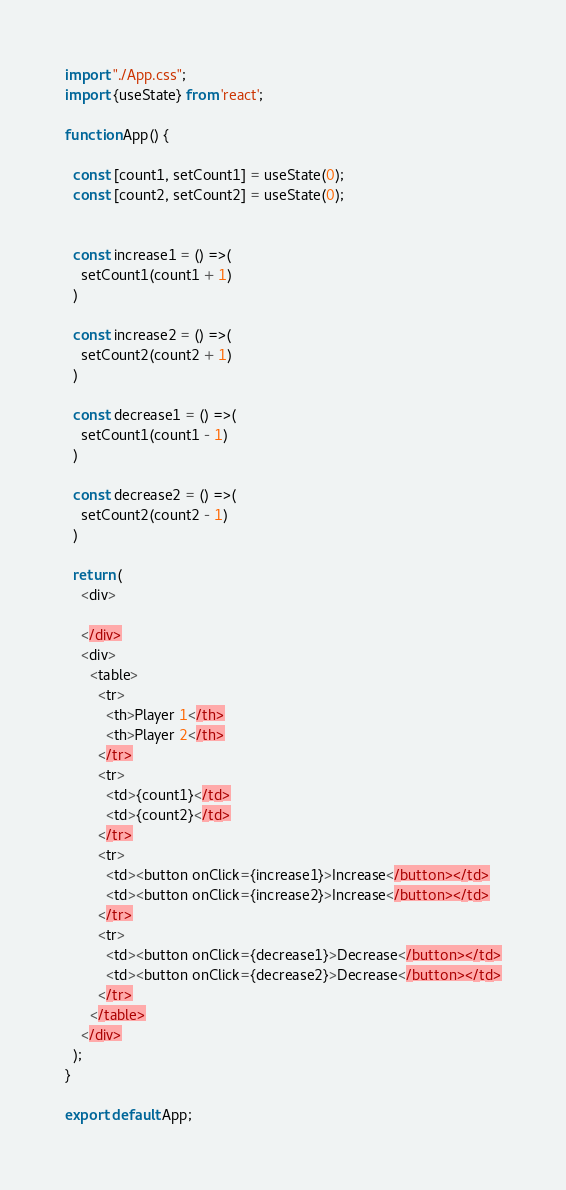<code> <loc_0><loc_0><loc_500><loc_500><_JavaScript_>import "./App.css";
import {useState} from 'react';

function App() {

  const [count1, setCount1] = useState(0);
  const [count2, setCount2] = useState(0);


  const increase1 = () =>(
    setCount1(count1 + 1)
  )

  const increase2 = () =>(
    setCount2(count2 + 1)
  )

  const decrease1 = () =>(
    setCount1(count1 - 1)
  )

  const decrease2 = () =>(
    setCount2(count2 - 1)
  )

  return (
    <div>
      
    </div>
    <div>
      <table>
        <tr>
          <th>Player 1</th>
          <th>Player 2</th>
        </tr>
        <tr>
          <td>{count1}</td>
          <td>{count2}</td>
        </tr>
        <tr>
          <td><button onClick={increase1}>Increase</button></td>
          <td><button onClick={increase2}>Increase</button></td>
        </tr>
        <tr>
          <td><button onClick={decrease1}>Decrease</button></td>
          <td><button onClick={decrease2}>Decrease</button></td>
        </tr>
      </table>
    </div>
  );
}

export default App;
</code> 